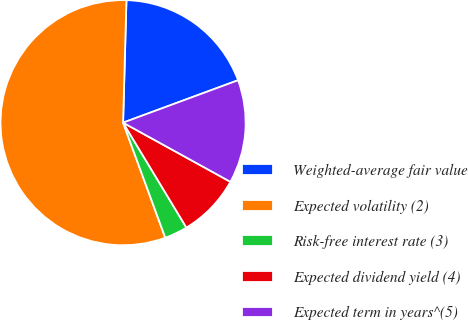Convert chart to OTSL. <chart><loc_0><loc_0><loc_500><loc_500><pie_chart><fcel>Weighted-average fair value<fcel>Expected volatility (2)<fcel>Risk-free interest rate (3)<fcel>Expected dividend yield (4)<fcel>Expected term in years^(5)<nl><fcel>18.94%<fcel>56.03%<fcel>3.05%<fcel>8.34%<fcel>13.64%<nl></chart> 